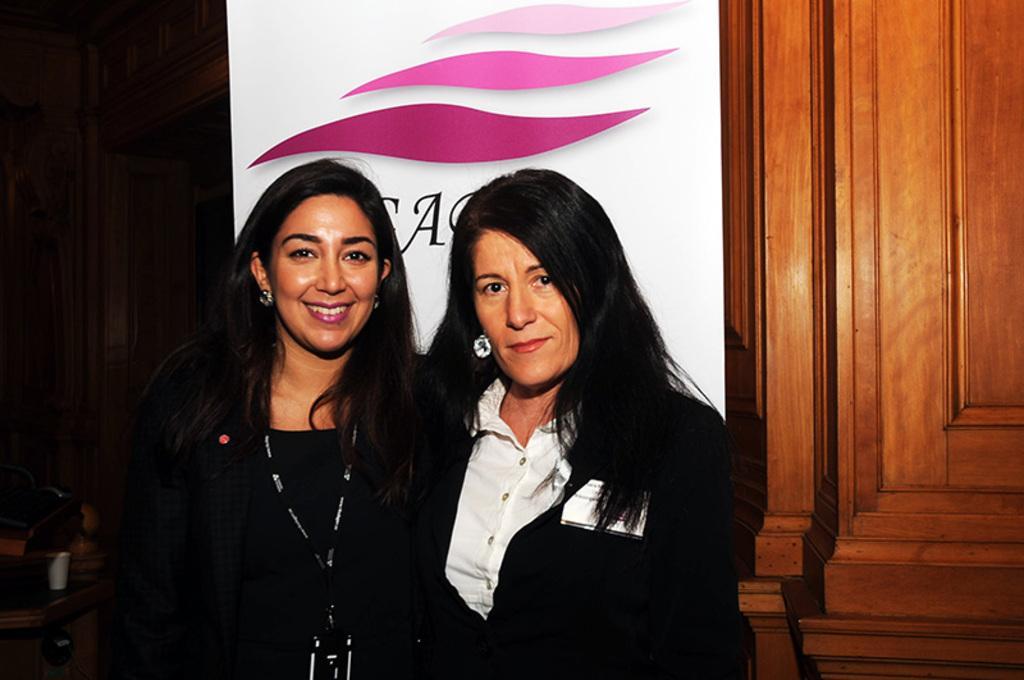How would you summarize this image in a sentence or two? In this image we can see two women smiling. In the background we can see a banner with the text. We can also see the wooden door. On the left there is a cup on the table. 